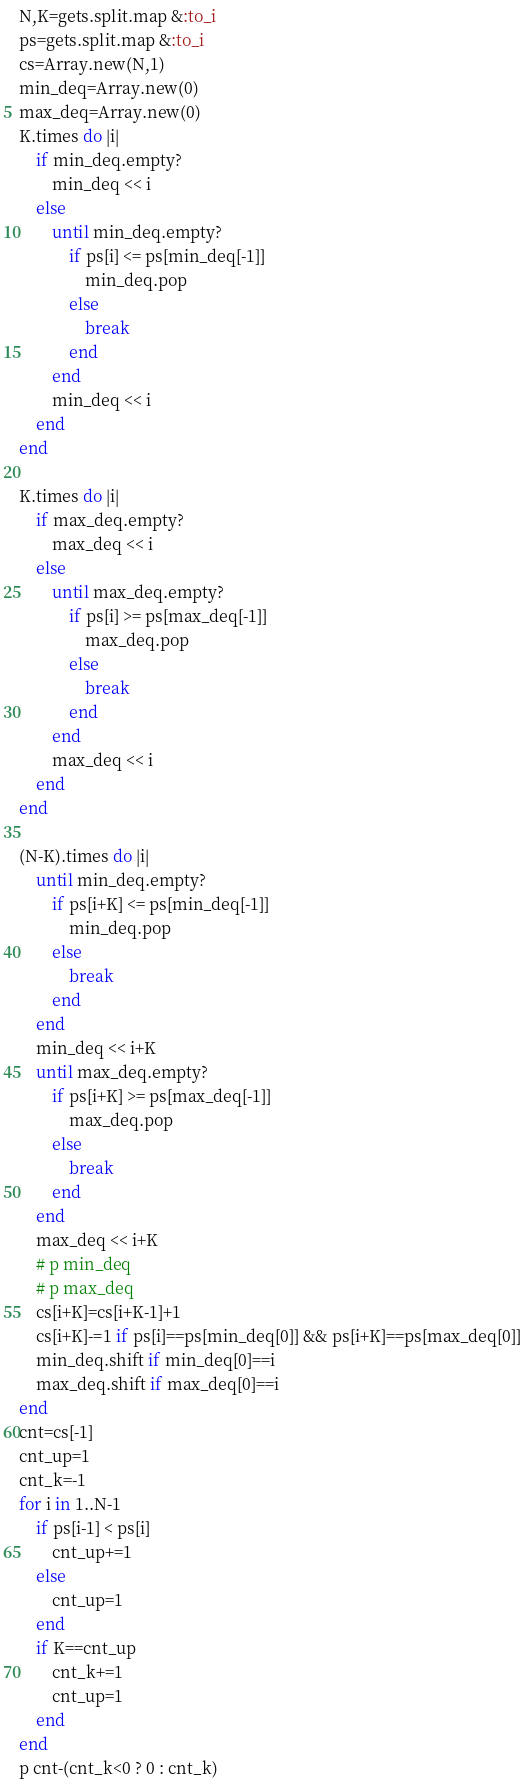Convert code to text. <code><loc_0><loc_0><loc_500><loc_500><_Ruby_>N,K=gets.split.map &:to_i
ps=gets.split.map &:to_i
cs=Array.new(N,1)
min_deq=Array.new(0)
max_deq=Array.new(0)
K.times do |i|
    if min_deq.empty?
        min_deq << i
    else
        until min_deq.empty?
            if ps[i] <= ps[min_deq[-1]]
                min_deq.pop
            else
                break
            end
        end
        min_deq << i
    end
end

K.times do |i|
    if max_deq.empty?
        max_deq << i
    else
        until max_deq.empty?
            if ps[i] >= ps[max_deq[-1]]
                max_deq.pop
            else
                break
            end
        end
        max_deq << i
    end
end

(N-K).times do |i|
    until min_deq.empty?
        if ps[i+K] <= ps[min_deq[-1]]
            min_deq.pop
        else
            break
        end
    end
    min_deq << i+K
    until max_deq.empty?
        if ps[i+K] >= ps[max_deq[-1]]
            max_deq.pop
        else
            break
        end
    end
    max_deq << i+K
    # p min_deq
    # p max_deq
    cs[i+K]=cs[i+K-1]+1
    cs[i+K]-=1 if ps[i]==ps[min_deq[0]] && ps[i+K]==ps[max_deq[0]]
    min_deq.shift if min_deq[0]==i
    max_deq.shift if max_deq[0]==i
end
cnt=cs[-1]
cnt_up=1
cnt_k=-1
for i in 1..N-1
    if ps[i-1] < ps[i]
        cnt_up+=1
    else
        cnt_up=1
    end
    if K==cnt_up
        cnt_k+=1
        cnt_up=1
    end
end
p cnt-(cnt_k<0 ? 0 : cnt_k)
</code> 